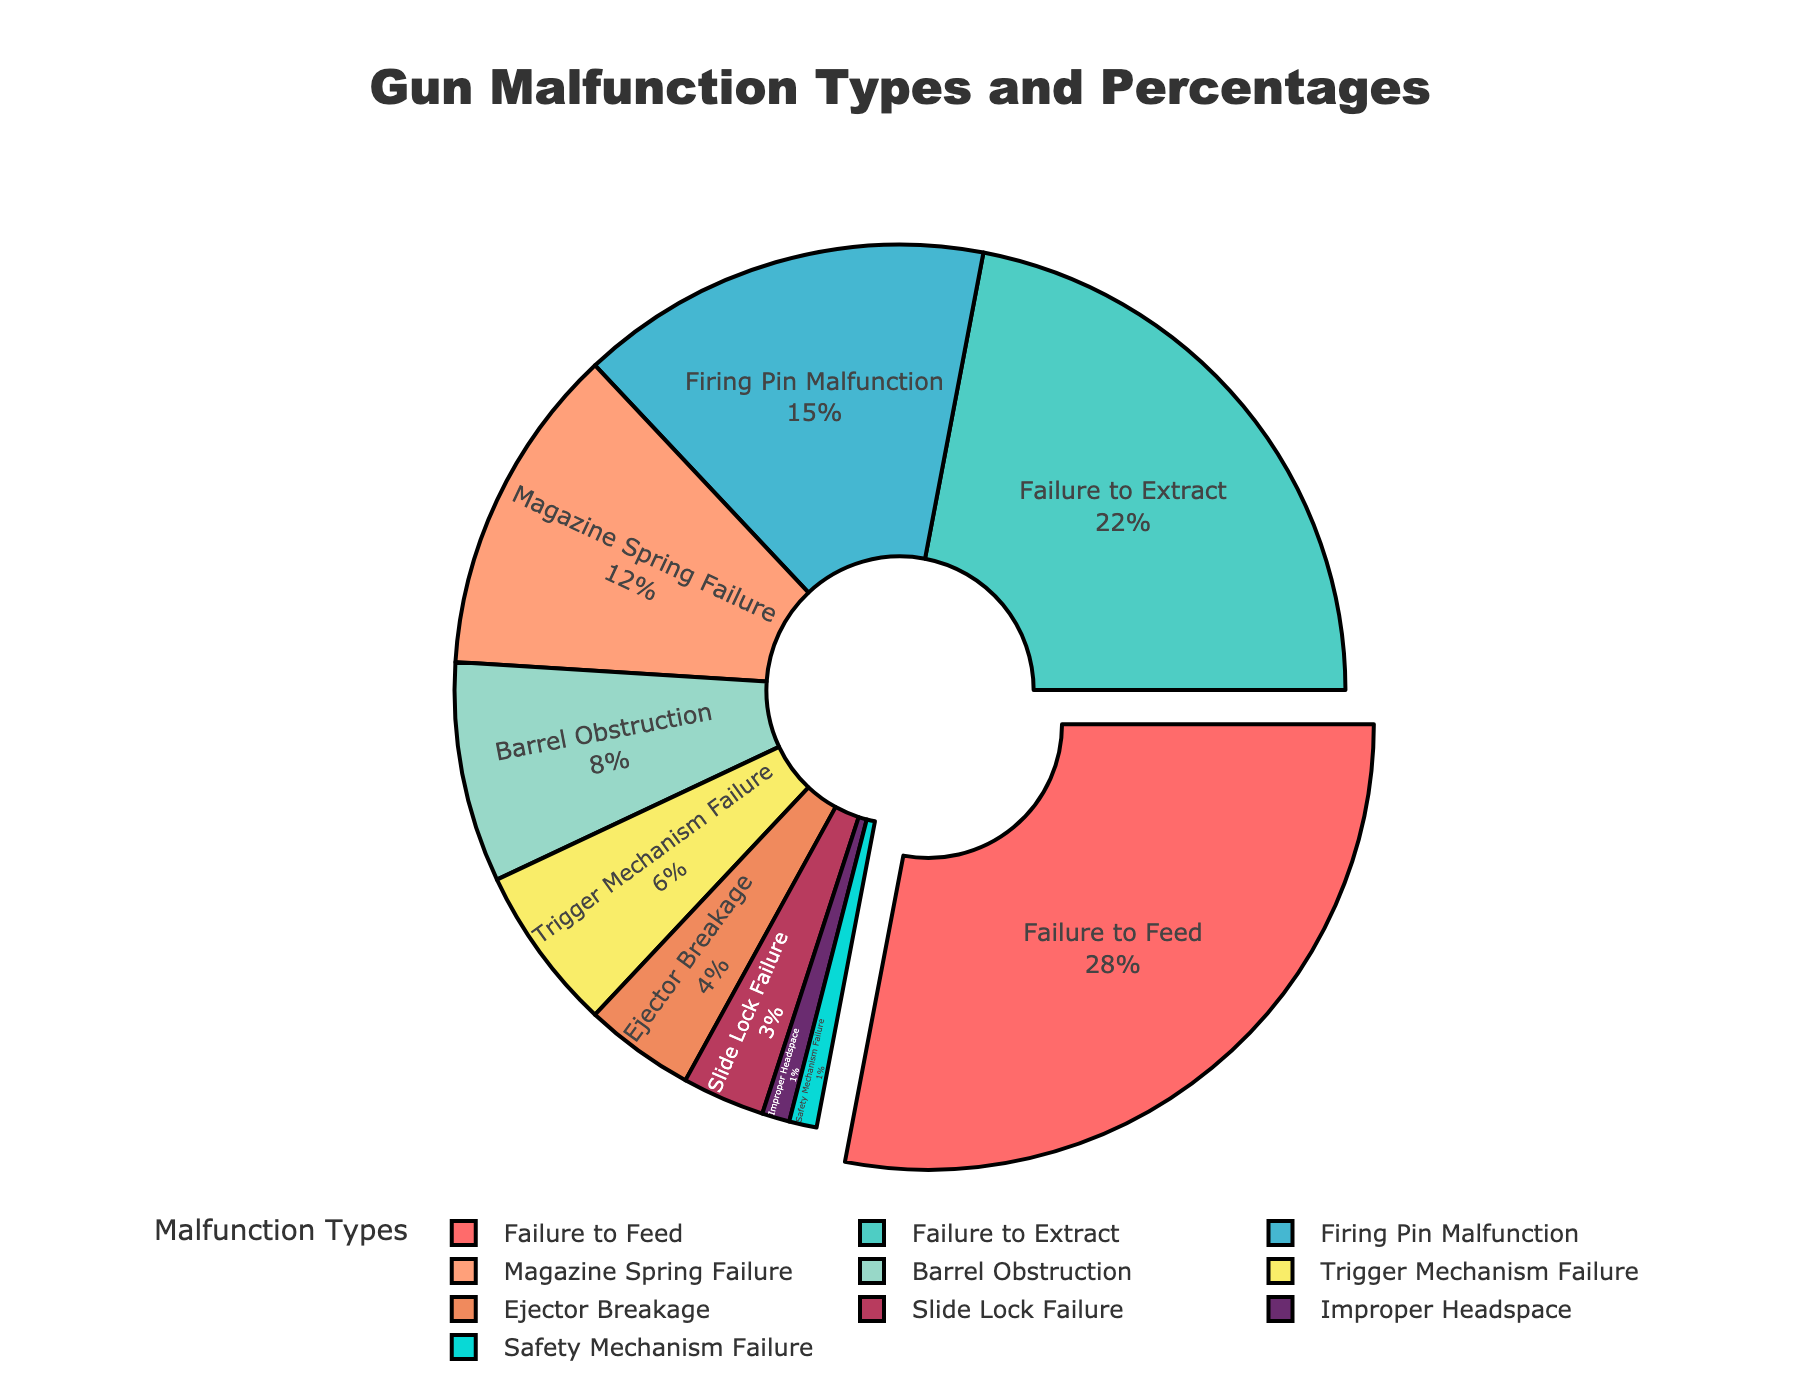What's the percentage of injuries caused by 'Failure to Feed'? Locate 'Failure to Feed' in the pie chart. The chart shows that 'Failure to Feed' causes 28% of the injuries.
Answer: 28% Which malfunction type has the lowest percentage of injuries? Find the segment with the smallest percentage. 'Safety Mechanism Failure' and 'Improper Headspace' both have the lowest at 1%.
Answer: Safety Mechanism Failure, Improper Headspace Which malfunction types have a combined percentage of over 40%? Identify the types and sum their percentages until the total exceeds 40%. 'Failure to Feed' (28%) and 'Failure to Extract' (22%) together make 50%.
Answer: Failure to Feed, Failure to Extract How many malfunction types account for less than 5% each? Find and count all segments that represent less than 5%. The segments are 'Ejector Breakage', 'Slide Lock Failure', 'Improper Headspace', and 'Safety Mechanism Failure', totaling four types.
Answer: Four What's the difference in percentage between 'Failure to Feed' and 'Failure to Extract'? Subtract the percentage of 'Failure to Extract' from 'Failure to Feed'. 28% - 22% = 6%.
Answer: 6% Is 'Magazine Spring Failure' responsible for more or less injuries compared to 'Trigger Mechanism Failure'? Compare the percentages of both types. 'Magazine Spring Failure' is 12% and 'Trigger Mechanism Failure' is 6%, so it is more.
Answer: More What's the combined percentage of injuries caused by 'Trigger Mechanism Failure' and 'Ejector Breakage'? Add their percentages together. 'Trigger Mechanism Failure' (6%) + 'Ejector Breakage' (4%) = 10%.
Answer: 10% What color represents 'Barrel Obstruction'? Look at the pie chart and find the color of the slice labeled 'Barrel Obstruction'. The chart uses orange (#FFA07A) for this segment.
Answer: Orange Which malfunction type's segment is pulled out from the pie chart and why? Identify the segment that appears pulled out. 'Failure to Feed' is pulled out because it has the highest percentage at 28%.
Answer: Failure to Feed What is the total percentage of injuries contributed by 'Firing Pin Malfunction', 'Magazine Spring Failure', and 'Trigger Mechanism Failure'? Sum up these percentages: 'Firing Pin Malfunction' (15%), 'Magazine Spring Failure' (12%), 'Trigger Mechanism Failure' (6%). 15% + 12% + 6% = 33%.
Answer: 33% 